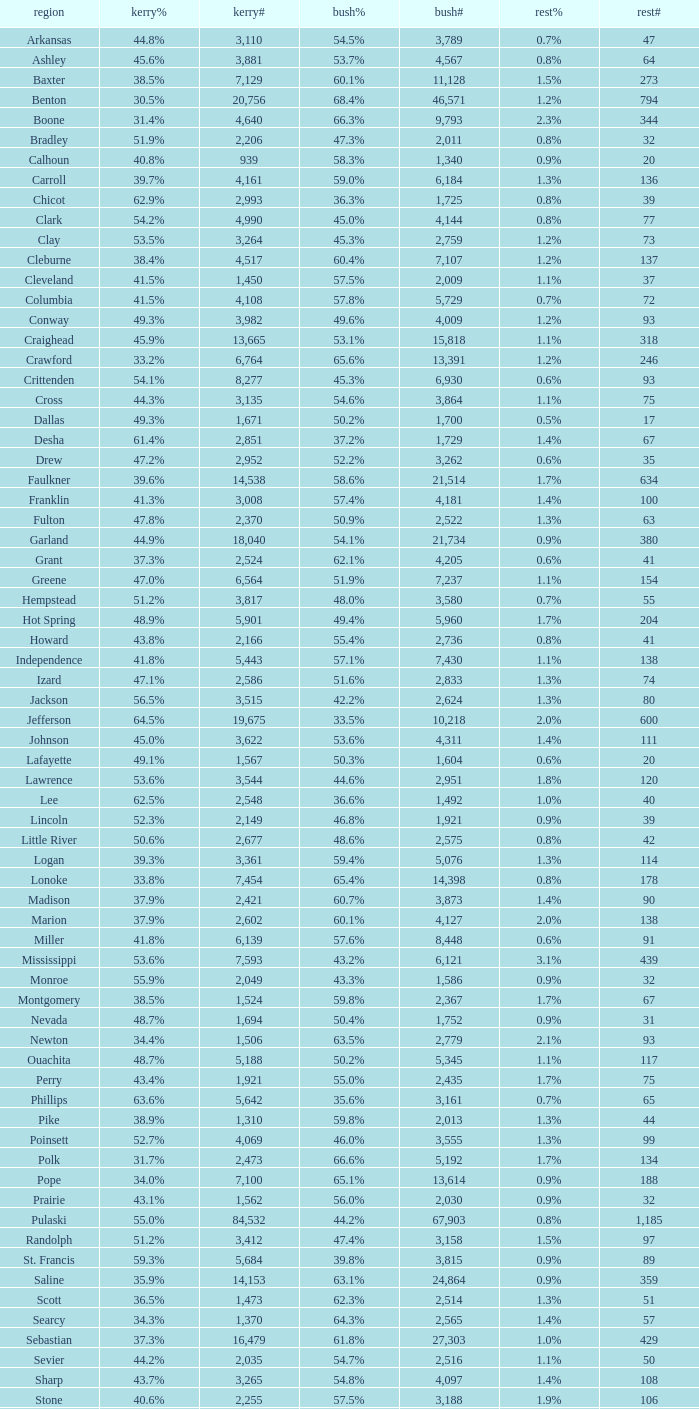What is the lowest Bush#, when Bush% is "65.4%"? 14398.0. 